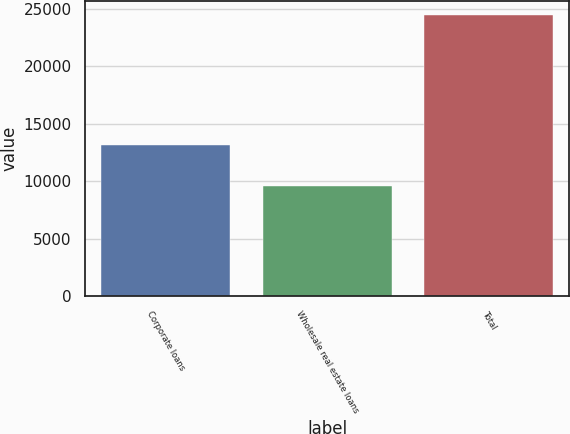<chart> <loc_0><loc_0><loc_500><loc_500><bar_chart><fcel>Corporate loans<fcel>Wholesale real estate loans<fcel>Total<nl><fcel>13170<fcel>9608<fcel>24476<nl></chart> 